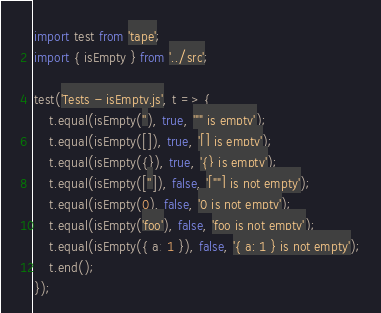Convert code to text. <code><loc_0><loc_0><loc_500><loc_500><_JavaScript_>import test from 'tape';
import { isEmpty } from '../src';

test('Tests - isEmpty.js', t => {
    t.equal(isEmpty(''), true, '"" is empty');
    t.equal(isEmpty([]), true, '[] is empty');
    t.equal(isEmpty({}), true, '{} is empty');
    t.equal(isEmpty(['']), false, '[""] is not empty');
    t.equal(isEmpty(0), false, '0 is not empty');
    t.equal(isEmpty('foo'), false, 'foo is not empty');
    t.equal(isEmpty({ a: 1 }), false, '{ a: 1 } is not empty');
    t.end();
});
</code> 